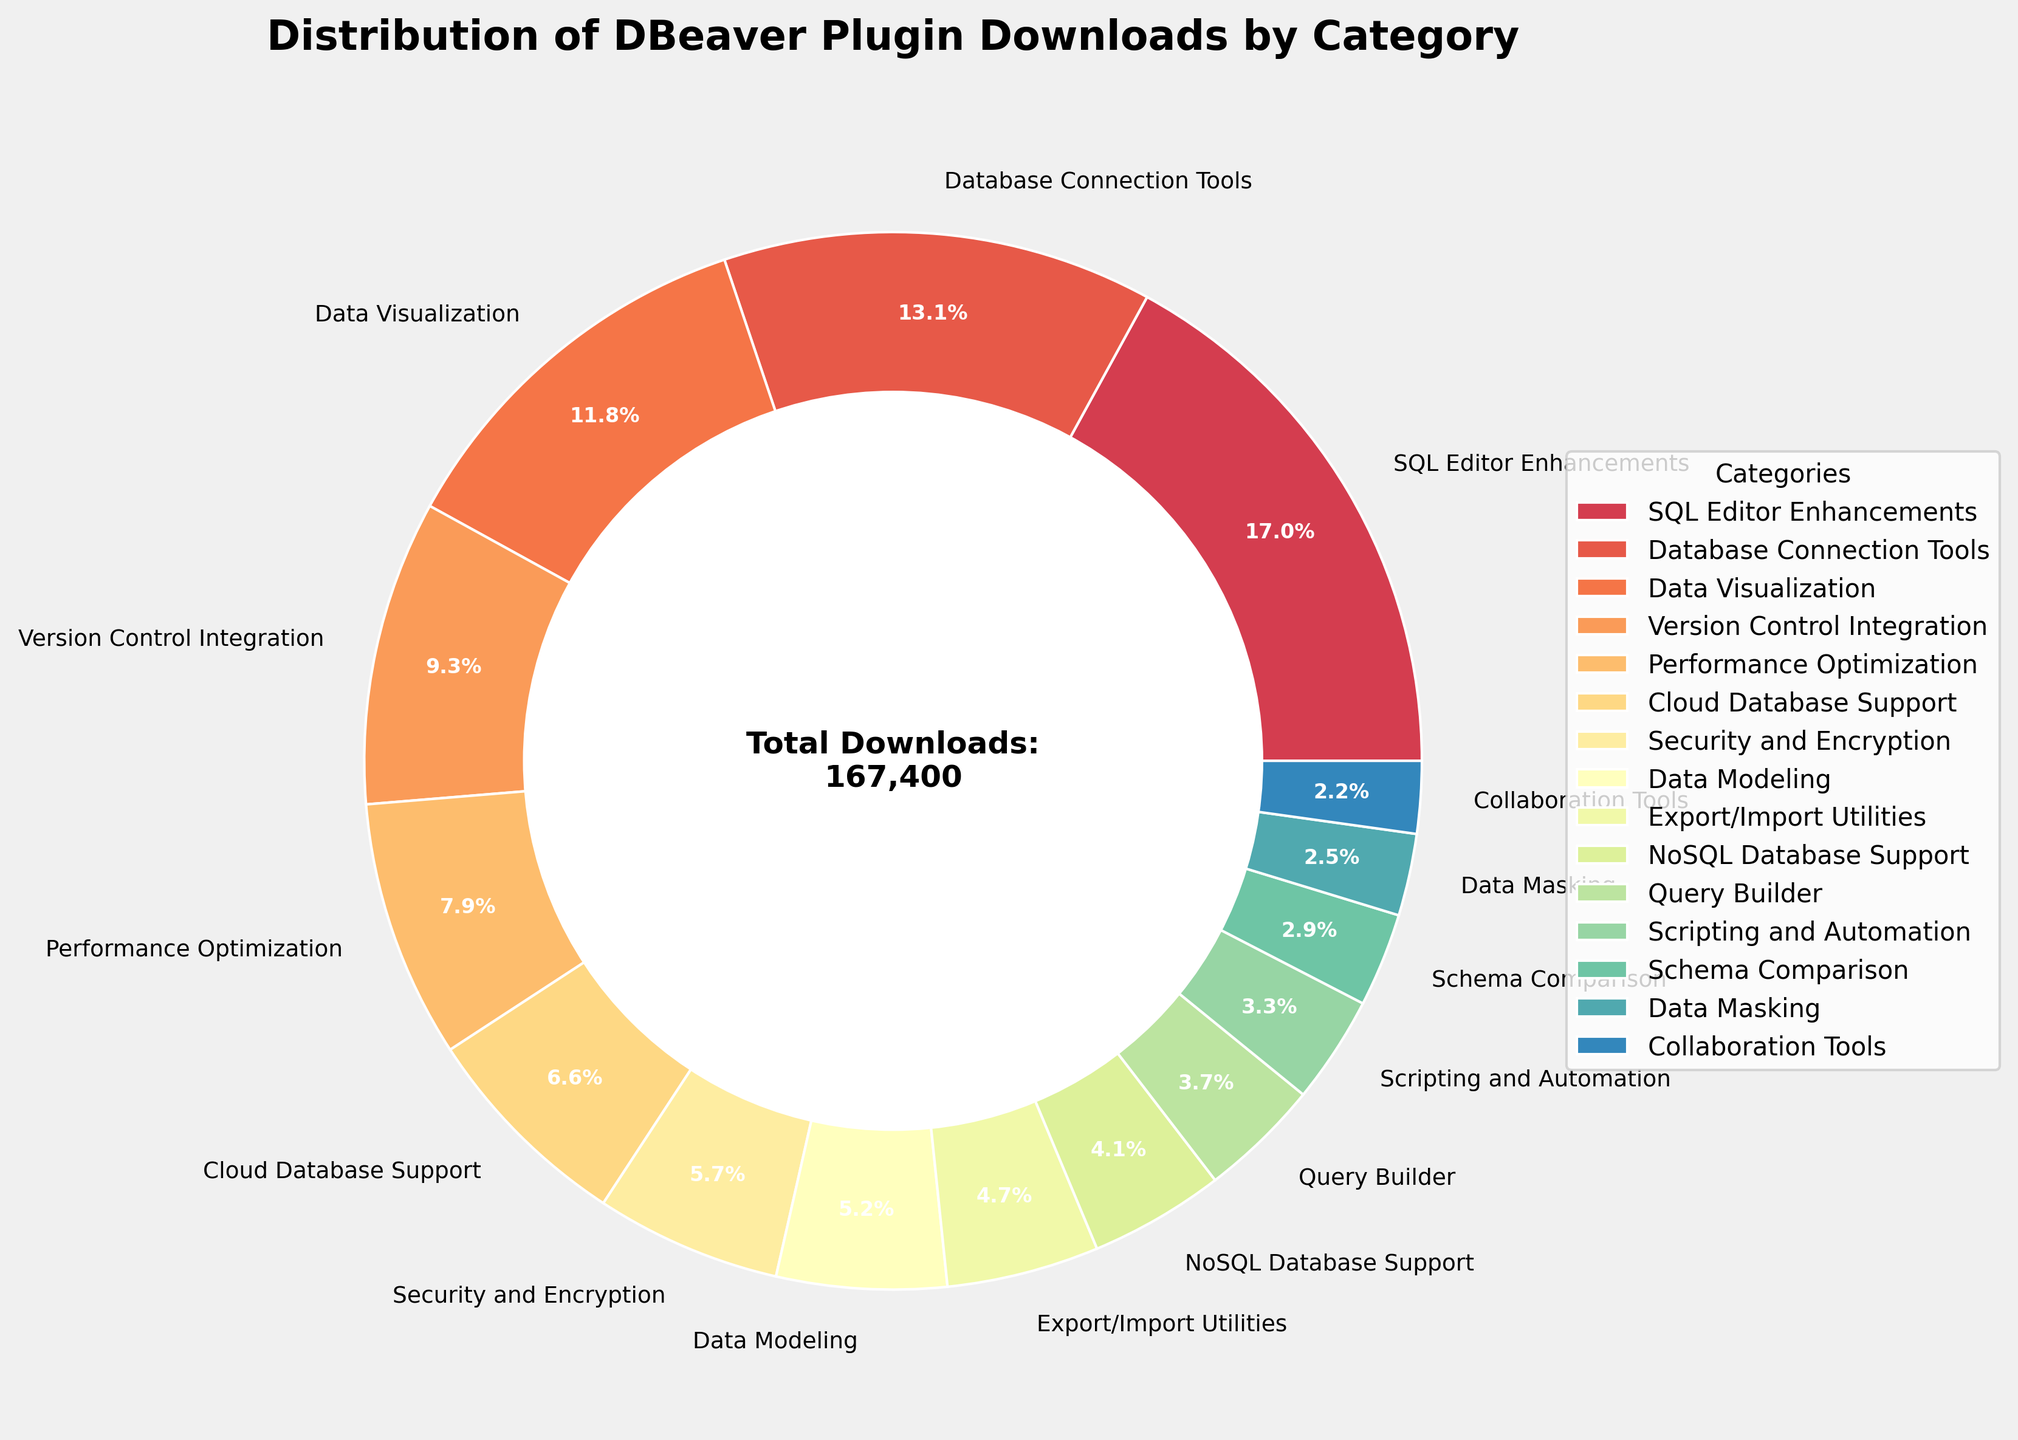Which category has the highest number of downloads? By looking at the pie chart, we can see that "SQL Editor Enhancements" has the largest slice. Therefore, it has the highest number of downloads.
Answer: SQL Editor Enhancements Which category has the lowest number of downloads? By looking at the pie chart, the smallest slice belongs to “Collaboration Tools,” indicating the lowest number of downloads.
Answer: Collaboration Tools What is the percentage of total downloads for "Database Connection Tools"? Find the slice for "Database Connection Tools" and read its percentage value shown in the chart, which is approximately 16.1%.
Answer: 16.1% How many categories have more than 10,000 downloads? Identify the categories with slices that represent more than 10,000 downloads by checking each segment and its value. The categories are: SQL Editor Enhancements, Database Connection Tools, Data Visualization, and Version Control Integration, making a total of 4 categories.
Answer: 4 What is the combined percentage of "NoSQL Database Support" and "Query Builder" downloads? Find the percentage values for "NoSQL Database Support" (4.9%) and "Query Builder" (4.4%) and sum them: 4.9% + 4.4% = 9.3%.
Answer: 9.3% How does the number of downloads for "Data Visualization" compare to "Performance Optimization"? Observe the sizes of their slices; "Data Visualization” has more downloads than "Performance Optimization". Specifically, "Data Visualization" has 19,800 downloads while "Performance Optimization" has 13,200 downloads.
Answer: Data Visualization has more downloads Are there more downloads for "Data Modeling" or "Export/Import Utilities"? Compare the slices for "Data Modeling" (8,700 downloads) and "Export/Import Utilities” (7,800 downloads). "Data Modeling" has more downloads than "Export/Import Utilities".
Answer: Data Modeling What is the total percentage of the top three categories by downloads? The top three categories are: SQL Editor Enhancements (27.9%), Database Connection Tools (21.6%), and Data Visualization (19.4%). Sum their percentages: 27.9% + 21.6% + 19.4% = 68.9%.
Answer: 68.9% By how many downloads does "Cloud Database Support" exceed "Security and Encryption"? "Cloud Database Support" has 11,000 downloads, and "Security and Encryption" has 9,500 downloads. The difference is 11,000 - 9,500 = 1,500 downloads.
Answer: 1,500 downloads What is the percentage contribution of "Schema Comparison" relative to the total downloads? First, identify the number of downloads for "Schema Comparison" (4,800). Calculate its percentage relative to the total downloads (183,500): (4,800/183,500) * 100 ≈ 2.6%.
Answer: 2.6% 